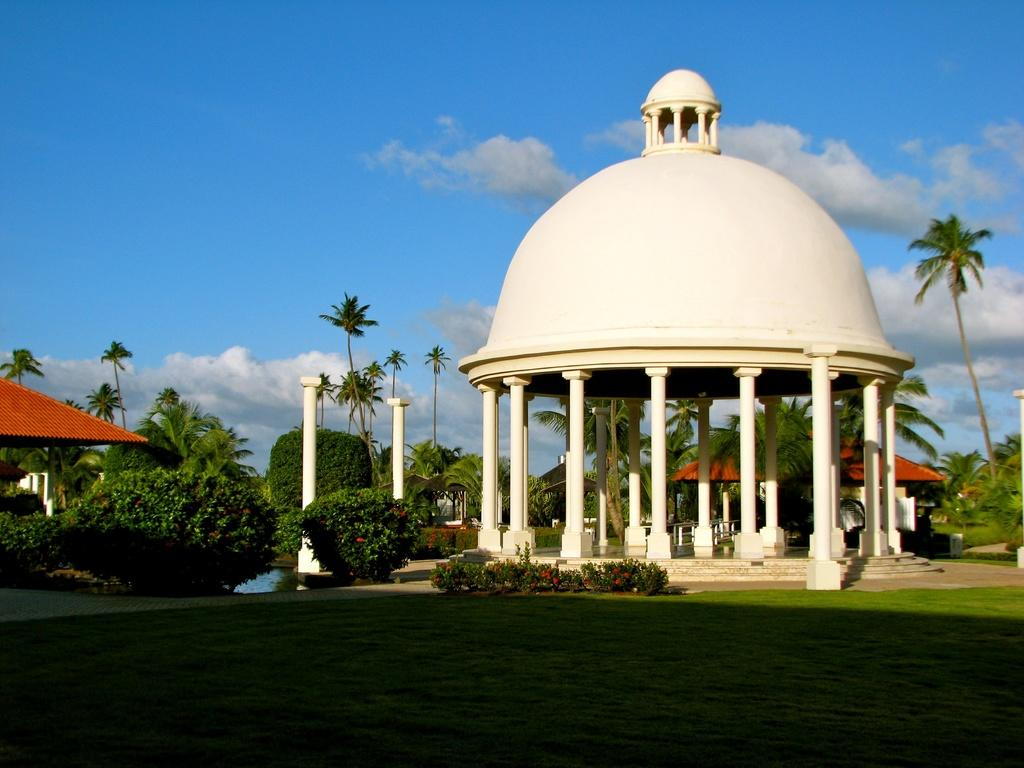What type of structure is depicted on pillars in the image? There is a dome on pillars in the image. What type of vegetation can be seen in the image? There are trees in the image. What architectural feature is present in the image? There are stairs in the image. What type of flora is present in the image? There are flowers in the image. What is the color of the sky in the image? The sky is blue and white in color. What type of trousers are hanging on the tree in the image? There are no trousers present in the image; it features a dome on pillars, trees, stairs, flowers, and a blue and white sky. 